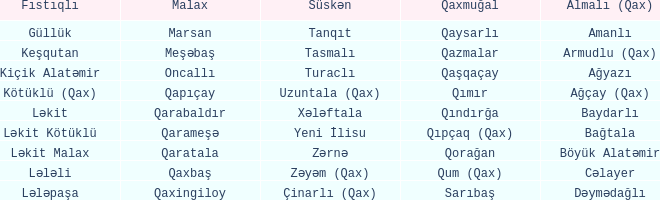What is the Qaxmuğal village with a Malax village meşəbaş? Qazmalar. 